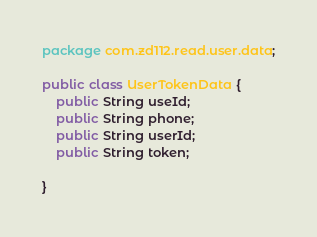<code> <loc_0><loc_0><loc_500><loc_500><_Java_>package com.zd112.read.user.data;

public class UserTokenData {
    public String useId;
    public String phone;
    public String userId;
    public String token;

}
</code> 